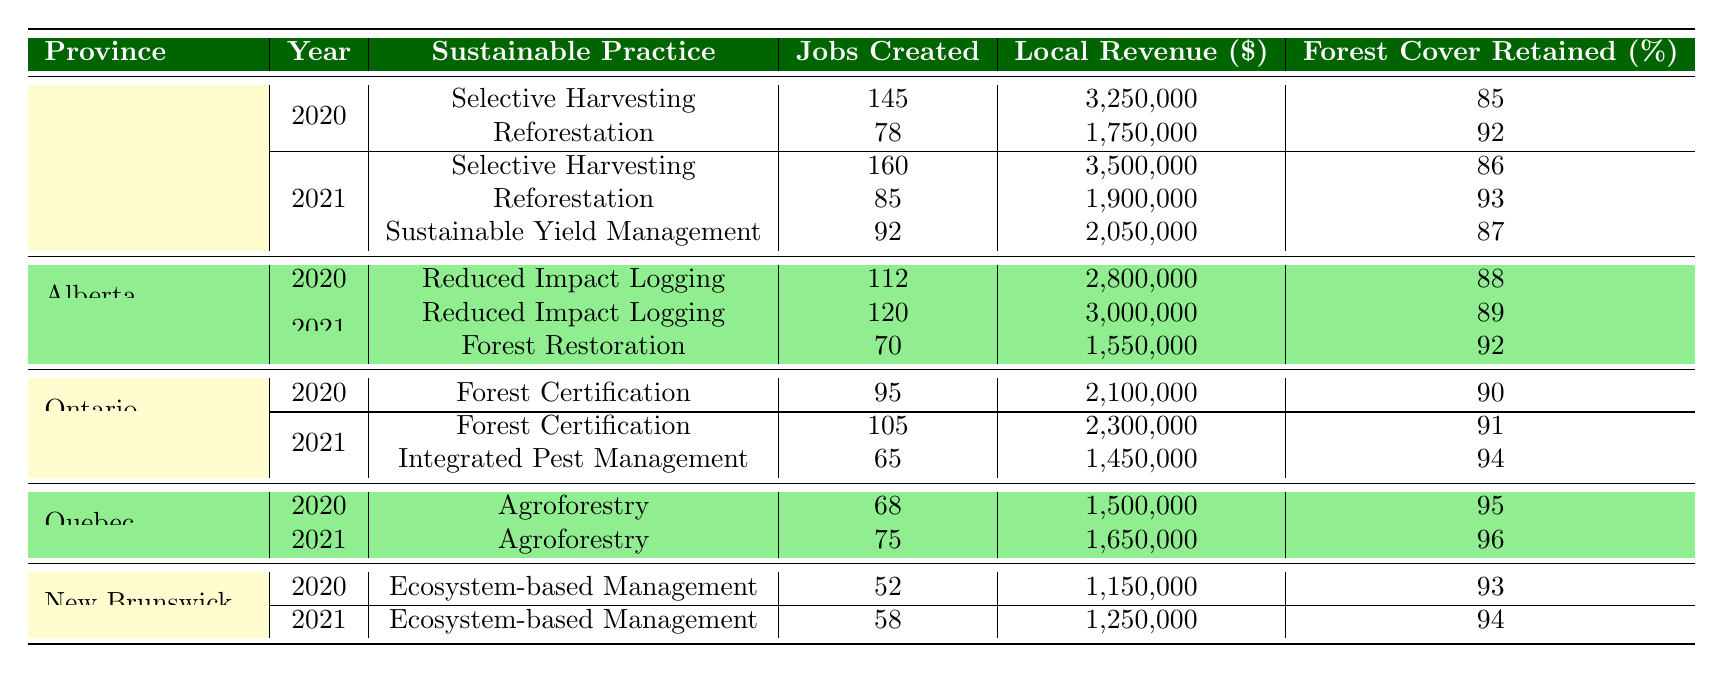What sustainable practice created the most jobs in British Columbia in 2021? In 2021, British Columbia had three sustainable practices listed: Selective Harvesting (160 jobs), Reforestation (85 jobs), and Sustainable Yield Management (92 jobs). The practice that created the most jobs is Selective Harvesting with 160 jobs created.
Answer: Selective Harvesting What was the local revenue generated by the Agroforestry practice in Quebec for the year 2020? In 2020, Agroforestry in Quebec (Saguenay) generated local revenue of 1,500,000. This value can be directly retrieved from the table under the specified province, community, and year.
Answer: 1,500,000 How many total jobs were created in Alberta across all practices in 2021? In 2021, the jobs created in Alberta were: Reduced Impact Logging (120 jobs) and Forest Restoration (70 jobs). Adding these together, 120 + 70 = 190 jobs were created in Alberta across all practices for that year.
Answer: 190 Did the Ecosystem-based Management practice in New Brunswick create more jobs in 2021 than in 2020? In New Brunswick, Ecosystem-based Management created 52 jobs in 2020 and 58 jobs in 2021. Since 58 (2021) is greater than 52 (2020), the answer is yes, it created more jobs in 2021.
Answer: Yes What is the difference in local revenue generated from Sustainable Yield Management in British Columbia between 2021 and 2020? In British Columbia, the local revenue from Sustainable Yield Management in 2021 is 2,050,000 and there is no revenue listed for 2020 for the same practice. Thus, the difference cannot be calculated and is considered as the revenue in 2020 is not present.
Answer: Not applicable What is the average forest cover retained across all sustainable practices listed in Ontario for 2021? In 2021, the practices in Ontario and their forest cover retained are Forest Certification (91%) and Integrated Pest Management (94%). To calculate the average, add these values: (91 + 94) and divide by the number of practices, which is 2. Therefore, (91 + 94) / 2 = 92.5.
Answer: 92.5 Which province had the highest local revenue from sustainable practices in 2021? In 2021, the local revenues from British Columbia were: Selective Harvesting (3,500,000), Reforestation (1,900,000), and Sustainable Yield Management (2,050,000). Adding these gives a total of 7,450,000, which is greater than revenues from other provinces. Thus, British Columbia had the highest local revenue in 2021.
Answer: British Columbia What percentage of forest cover was retained by Reduce Impact Logging in Alberta in 2021? The table shows that the forest cover retained by Reduced Impact Logging in Alberta in 2021 was 89%. This value is clearly stated in the relevant row under Alberta for 2021.
Answer: 89% 